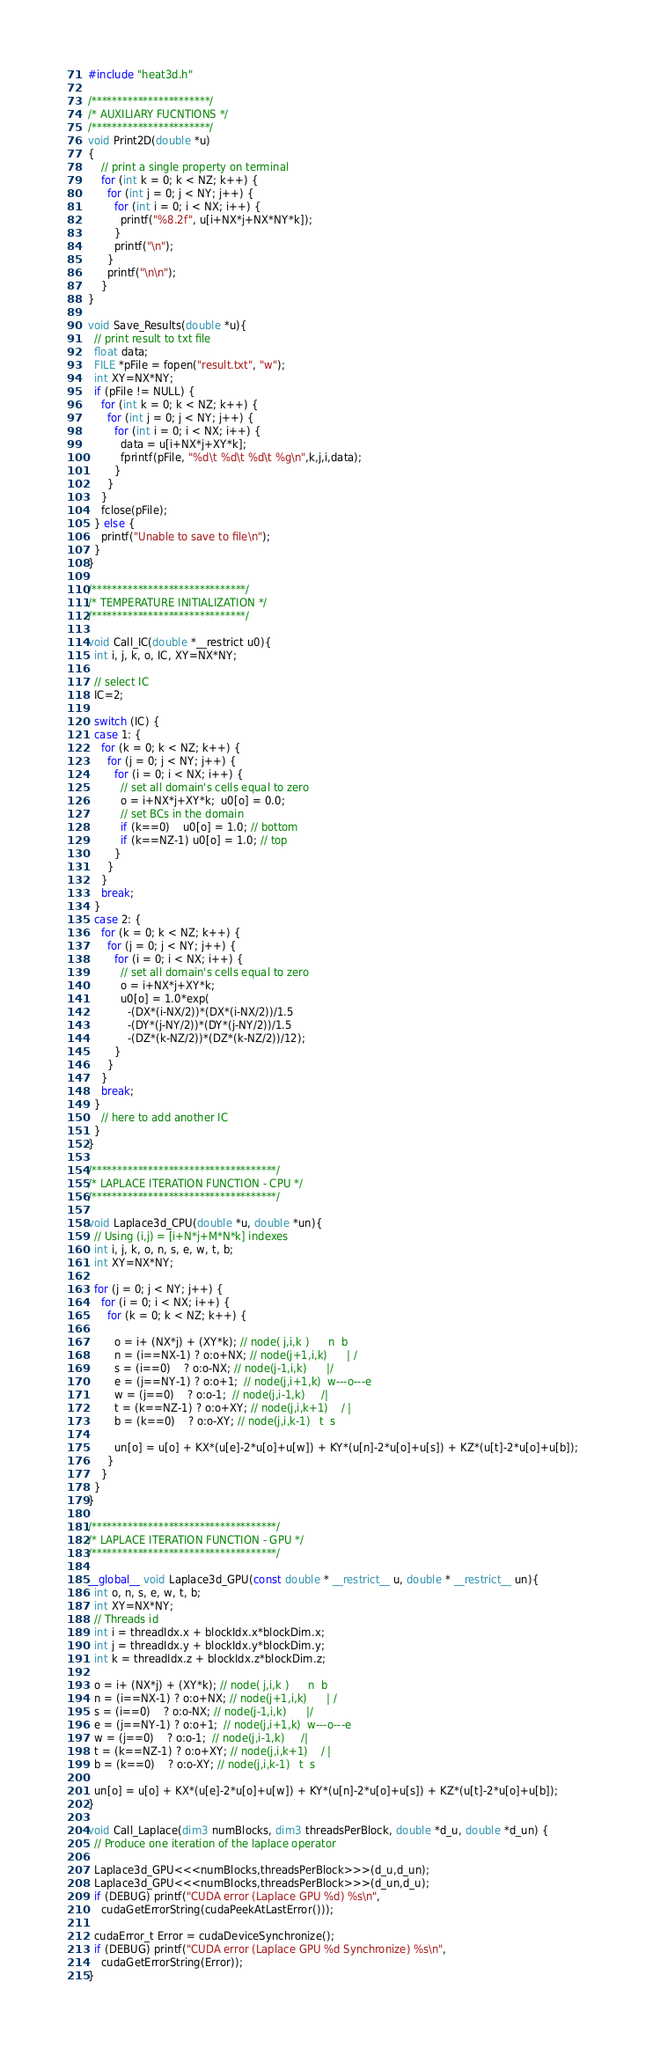Convert code to text. <code><loc_0><loc_0><loc_500><loc_500><_Cuda_>
#include "heat3d.h"

/***********************/
/* AUXILIARY FUCNTIONS */
/***********************/
void Print2D(double *u)
{
    // print a single property on terminal
    for (int k = 0; k < NZ; k++) {
      for (int j = 0; j < NY; j++) {
        for (int i = 0; i < NX; i++) {
          printf("%8.2f", u[i+NX*j+NX*NY*k]);
        }
        printf("\n");
      }
      printf("\n\n");
    }
}

void Save_Results(double *u){
  // print result to txt file
  float data;
  FILE *pFile = fopen("result.txt", "w");  
  int XY=NX*NY;
  if (pFile != NULL) {
    for (int k = 0; k < NZ; k++) {
      for (int j = 0; j < NY; j++) {
        for (int i = 0; i < NX; i++) {
          data = u[i+NX*j+XY*k];
          fprintf(pFile, "%d\t %d\t %d\t %g\n",k,j,i,data);
        }
      }
    }
    fclose(pFile);
  } else {
    printf("Unable to save to file\n");
  }
}

/******************************/
/* TEMPERATURE INITIALIZATION */
/******************************/

void Call_IC(double *__restrict u0){
  int i, j, k, o, IC, XY=NX*NY;

  // select IC
  IC=2;

  switch (IC) {
  case 1: {
    for (k = 0; k < NZ; k++) {
      for (j = 0; j < NY; j++) {
      	for (i = 0; i < NX; i++) {
      	  // set all domain's cells equal to zero
      	  o = i+NX*j+XY*k;  u0[o] = 0.0;
      	  // set BCs in the domain 
      	  if (k==0)    u0[o] = 1.0; // bottom
      	  if (k==NZ-1) u0[o] = 1.0; // top
      	}
      }
    }
    break;
  }
  case 2: {
    for (k = 0; k < NZ; k++) {
      for (j = 0; j < NY; j++) {
        for (i = 0; i < NX; i++) {
          // set all domain's cells equal to zero
          o = i+NX*j+XY*k;  
          u0[o] = 1.0*exp(
            -(DX*(i-NX/2))*(DX*(i-NX/2))/1.5
            -(DY*(j-NY/2))*(DY*(j-NY/2))/1.5
            -(DZ*(k-NZ/2))*(DZ*(k-NZ/2))/12);
        }
      }
    }
    break;
  }
    // here to add another IC
  } 
}

/************************************/
/* LAPLACE ITERATION FUNCTION - CPU */
/************************************/

void Laplace3d_CPU(double *u, double *un){
  // Using (i,j) = [i+N*j+M*N*k] indexes
  int i, j, k, o, n, s, e, w, t, b; 
  int XY=NX*NY;

  for (j = 0; j < NY; j++) {
    for (i = 0; i < NX; i++) {
      for (k = 0; k < NZ; k++) {
	
        o = i+ (NX*j) + (XY*k); // node( j,i,k )      n  b
        n = (i==NX-1) ? o:o+NX; // node(j+1,i,k)      | /
        s = (i==0)    ? o:o-NX; // node(j-1,i,k)      |/
        e = (j==NY-1) ? o:o+1;  // node(j,i+1,k)  w---o---e
        w = (j==0)    ? o:o-1;  // node(j,i-1,k)     /|
        t = (k==NZ-1) ? o:o+XY; // node(j,i,k+1)    / |
        b = (k==0)    ? o:o-XY; // node(j,i,k-1)   t  s

        un[o] = u[o] + KX*(u[e]-2*u[o]+u[w]) + KY*(u[n]-2*u[o]+u[s]) + KZ*(u[t]-2*u[o]+u[b]);
      }
    } 
  }
}

/************************************/
/* LAPLACE ITERATION FUNCTION - GPU */
/************************************/

__global__ void Laplace3d_GPU(const double * __restrict__ u, double * __restrict__ un){
  int o, n, s, e, w, t, b;  
  int XY=NX*NY;
  // Threads id
  int i = threadIdx.x + blockIdx.x*blockDim.x;
  int j = threadIdx.y + blockIdx.y*blockDim.y;
  int k = threadIdx.z + blockIdx.z*blockDim.z;

  o = i+ (NX*j) + (XY*k); // node( j,i,k )      n  b
  n = (i==NX-1) ? o:o+NX; // node(j+1,i,k)      | /
  s = (i==0)    ? o:o-NX; // node(j-1,i,k)      |/
  e = (j==NY-1) ? o:o+1;  // node(j,i+1,k)  w---o---e
  w = (j==0)    ? o:o-1;  // node(j,i-1,k)     /|
  t = (k==NZ-1) ? o:o+XY; // node(j,i,k+1)    / |
  b = (k==0)    ? o:o-XY; // node(j,i,k-1)   t  s

  un[o] = u[o] + KX*(u[e]-2*u[o]+u[w]) + KY*(u[n]-2*u[o]+u[s]) + KZ*(u[t]-2*u[o]+u[b]);
}

void Call_Laplace(dim3 numBlocks, dim3 threadsPerBlock, double *d_u, double *d_un) {
  // Produce one iteration of the laplace operator

  Laplace3d_GPU<<<numBlocks,threadsPerBlock>>>(d_u,d_un);
  Laplace3d_GPU<<<numBlocks,threadsPerBlock>>>(d_un,d_u);
  if (DEBUG) printf("CUDA error (Laplace GPU %d) %s\n",
    cudaGetErrorString(cudaPeekAtLastError()));

  cudaError_t Error = cudaDeviceSynchronize();
  if (DEBUG) printf("CUDA error (Laplace GPU %d Synchronize) %s\n",
    cudaGetErrorString(Error));
}
</code> 